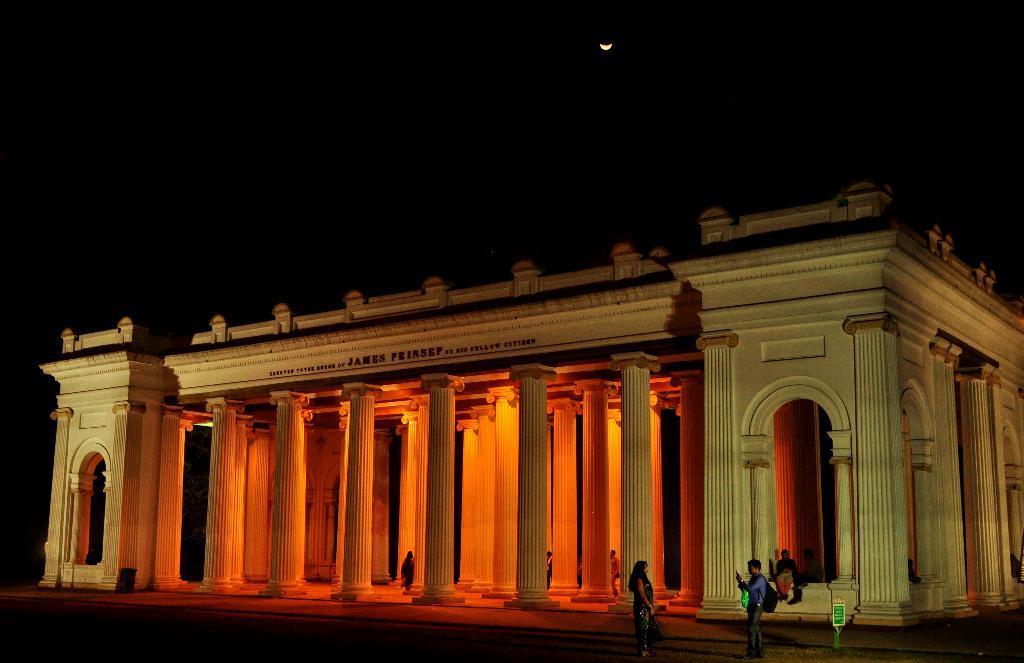Please provide a concise description of this image. In this image, we can see a building with people in it and two of them are standing in front of the building. The sky is dark in color with the moon. 